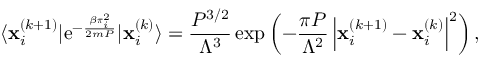Convert formula to latex. <formula><loc_0><loc_0><loc_500><loc_500>\langle x _ { i } ^ { ( k + 1 ) } | e ^ { - \frac { \beta \pi _ { i } ^ { 2 } } { 2 m P } } | x _ { i } ^ { ( k ) } \rangle = \frac { P ^ { 3 / 2 } } { \Lambda ^ { 3 } } \exp \left ( - \frac { \pi P } { \Lambda ^ { 2 } } \left | x _ { i } ^ { ( k + 1 ) } - x _ { i } ^ { ( k ) } \right | ^ { 2 } \right ) ,</formula> 